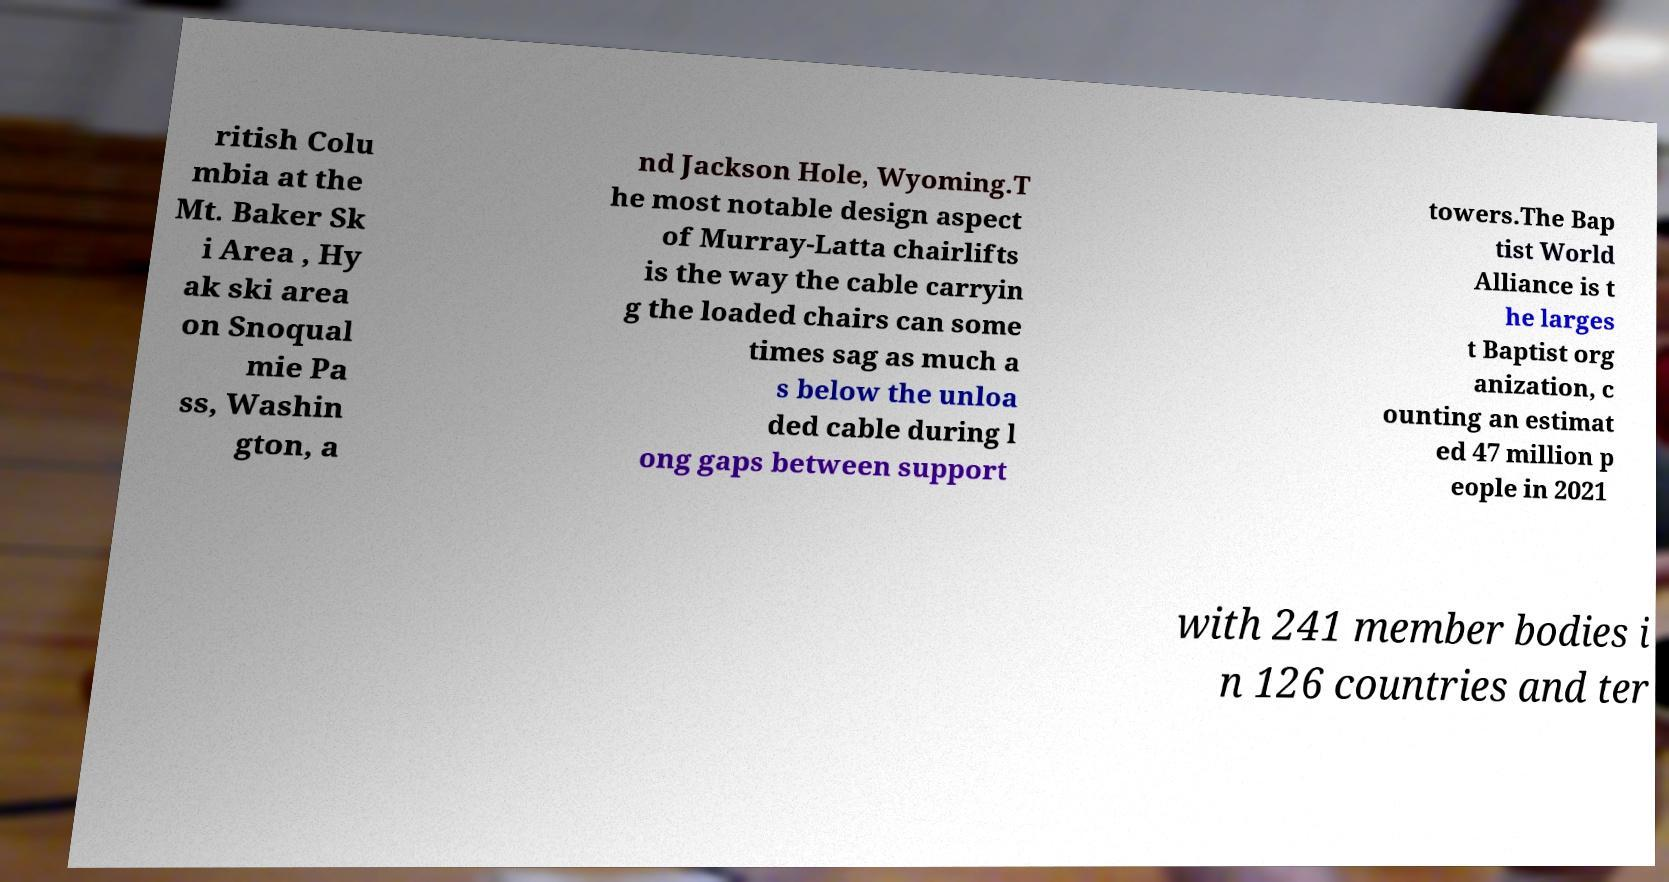Can you accurately transcribe the text from the provided image for me? ritish Colu mbia at the Mt. Baker Sk i Area , Hy ak ski area on Snoqual mie Pa ss, Washin gton, a nd Jackson Hole, Wyoming.T he most notable design aspect of Murray-Latta chairlifts is the way the cable carryin g the loaded chairs can some times sag as much a s below the unloa ded cable during l ong gaps between support towers.The Bap tist World Alliance is t he larges t Baptist org anization, c ounting an estimat ed 47 million p eople in 2021 with 241 member bodies i n 126 countries and ter 